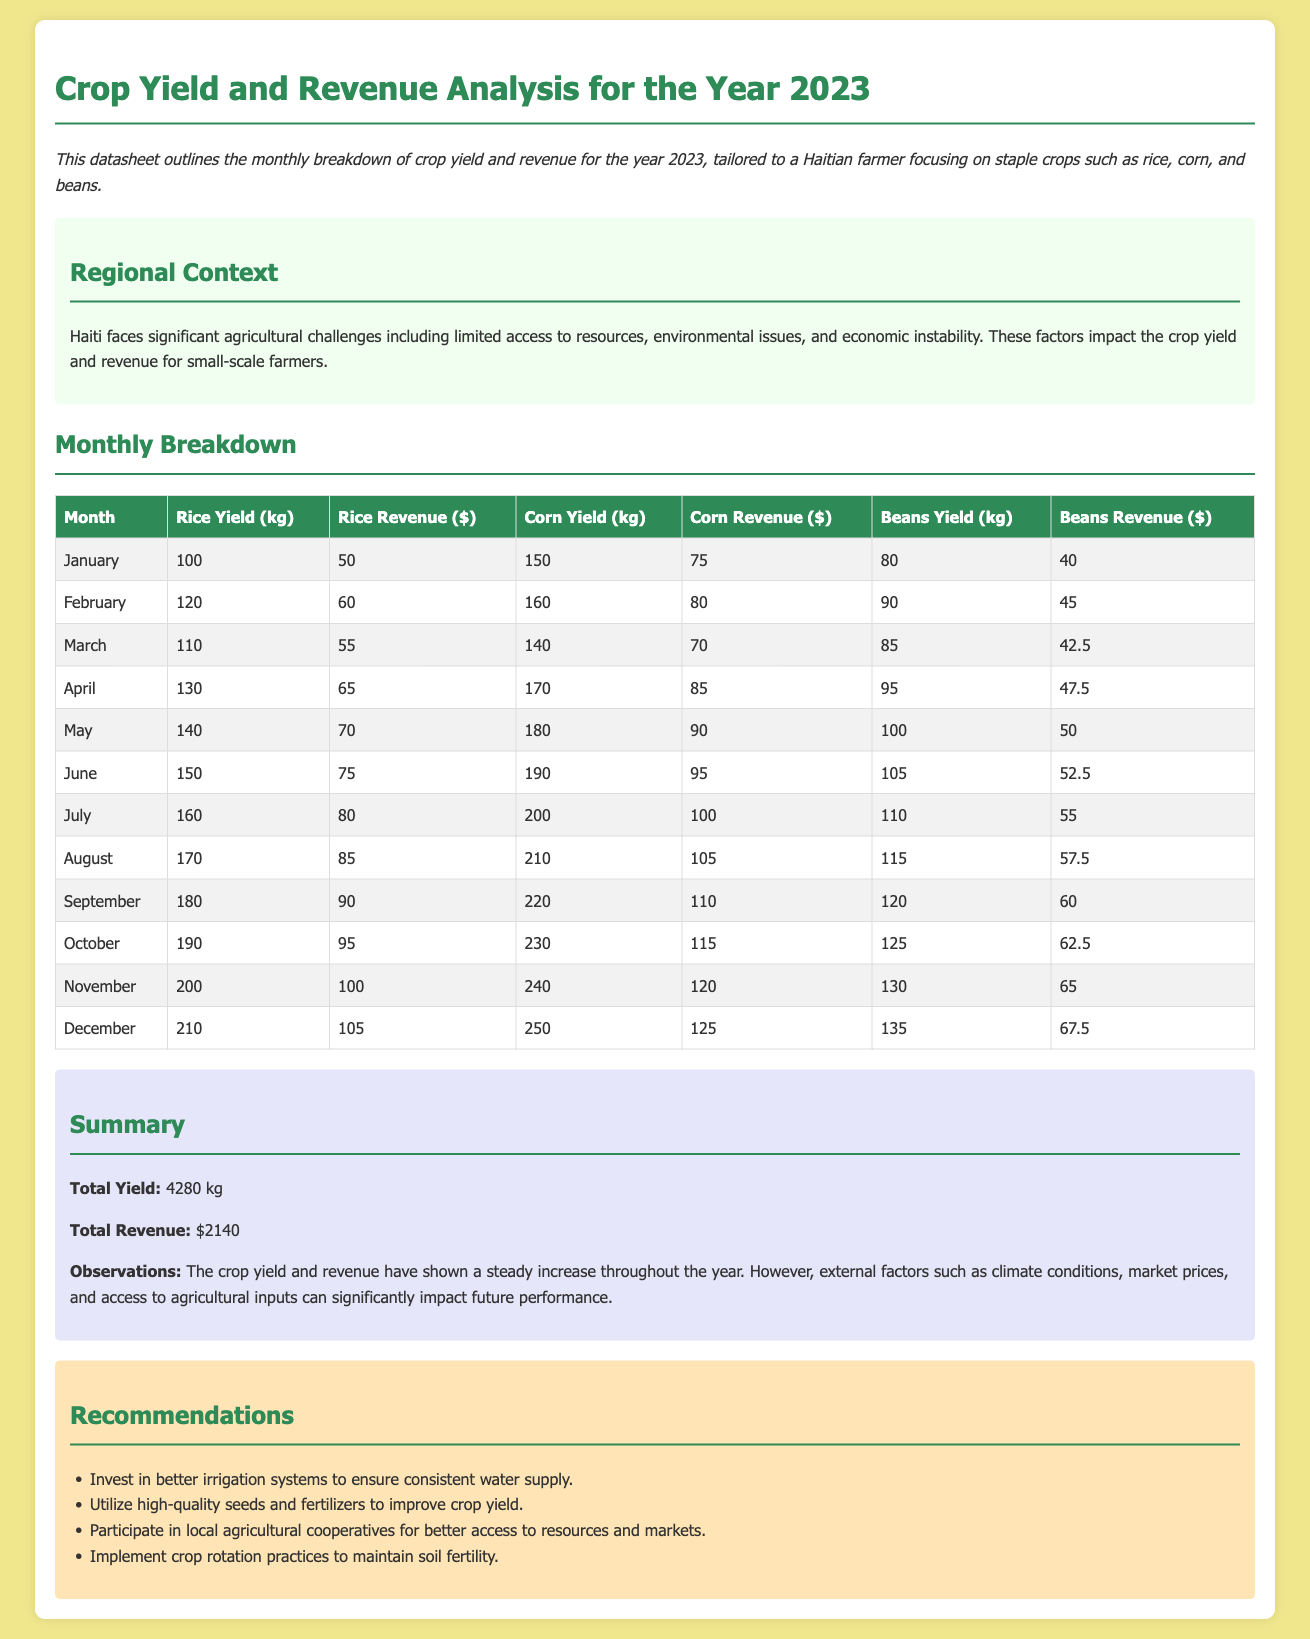What is the total yield for the year? The total yield is the aggregate of all crop yields throughout the year, which is stated as 4280 kg in the summary section.
Answer: 4280 kg What was the revenue from beans in August? The revenue from beans in August is directly given in the monthly breakdown table, which is 57.5 dollars.
Answer: 57.5 Which month had the highest rice yield? By examining the monthly breakdown table, the month with the highest rice yield is December with 210 kg.
Answer: December What is the total revenue for the year? The total revenue is calculated from the sum of all monthly revenues, as specified in the summary, totaling 2140 dollars.
Answer: 2140 dollars Which crop had the lowest revenue in January? By analyzing the January revenue figures in the monthly breakdown, the crop with the lowest revenue is beans, with 40 dollars.
Answer: Beans How many kilograms of corn were yielded in October? The amount of corn yield for October is stated directly in the table as 230 kg.
Answer: 230 kg What is one recommendation for improving crop yield? The recommendations section lists several suggestions, among which is to invest in better irrigation systems.
Answer: Invest in better irrigation systems How much rice revenue was reported in March? From the monthly breakdown table, the rice revenue in March is clearly stated as 55 dollars.
Answer: 55 dollars What does the document mainly focus on? The primary focus of the document is on crop yield and revenue analysis for the year 2023.
Answer: Crop yield and revenue analysis 